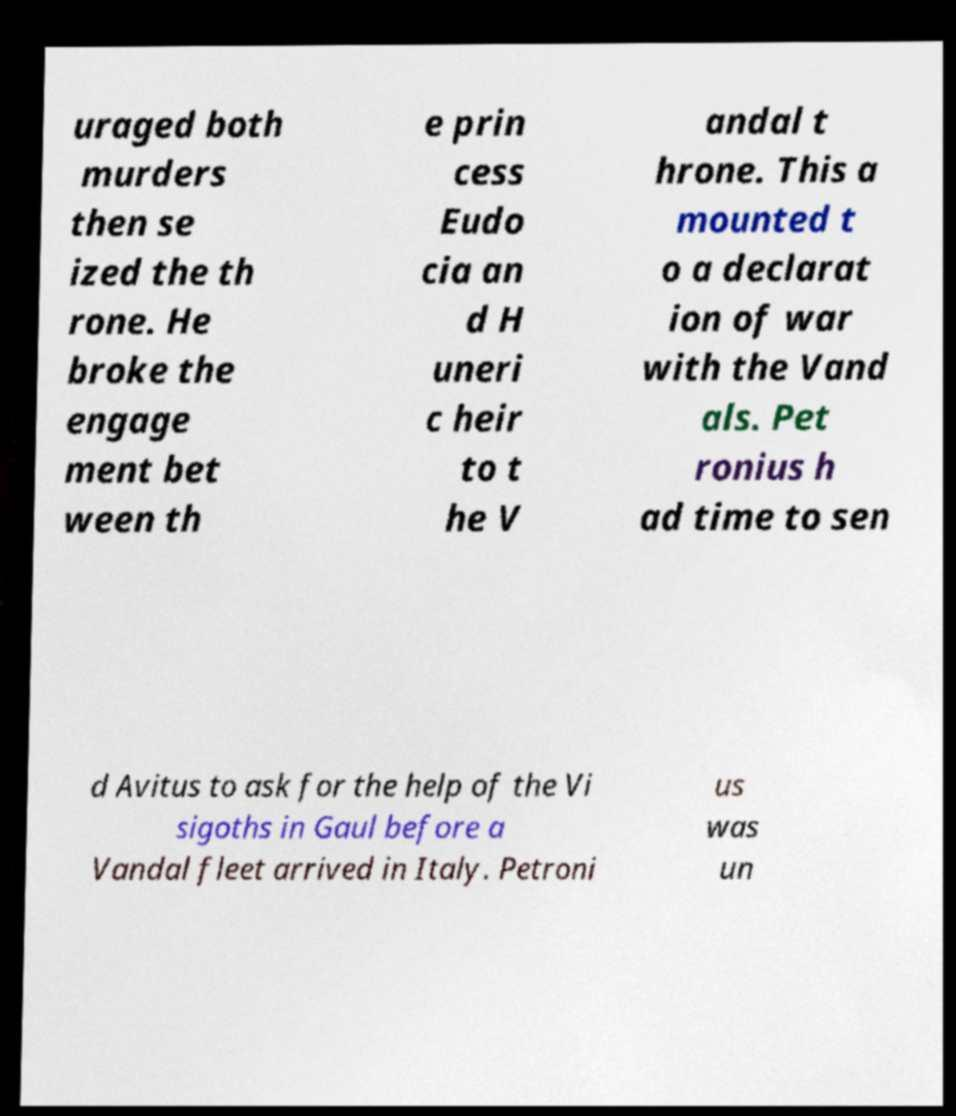Please identify and transcribe the text found in this image. uraged both murders then se ized the th rone. He broke the engage ment bet ween th e prin cess Eudo cia an d H uneri c heir to t he V andal t hrone. This a mounted t o a declarat ion of war with the Vand als. Pet ronius h ad time to sen d Avitus to ask for the help of the Vi sigoths in Gaul before a Vandal fleet arrived in Italy. Petroni us was un 